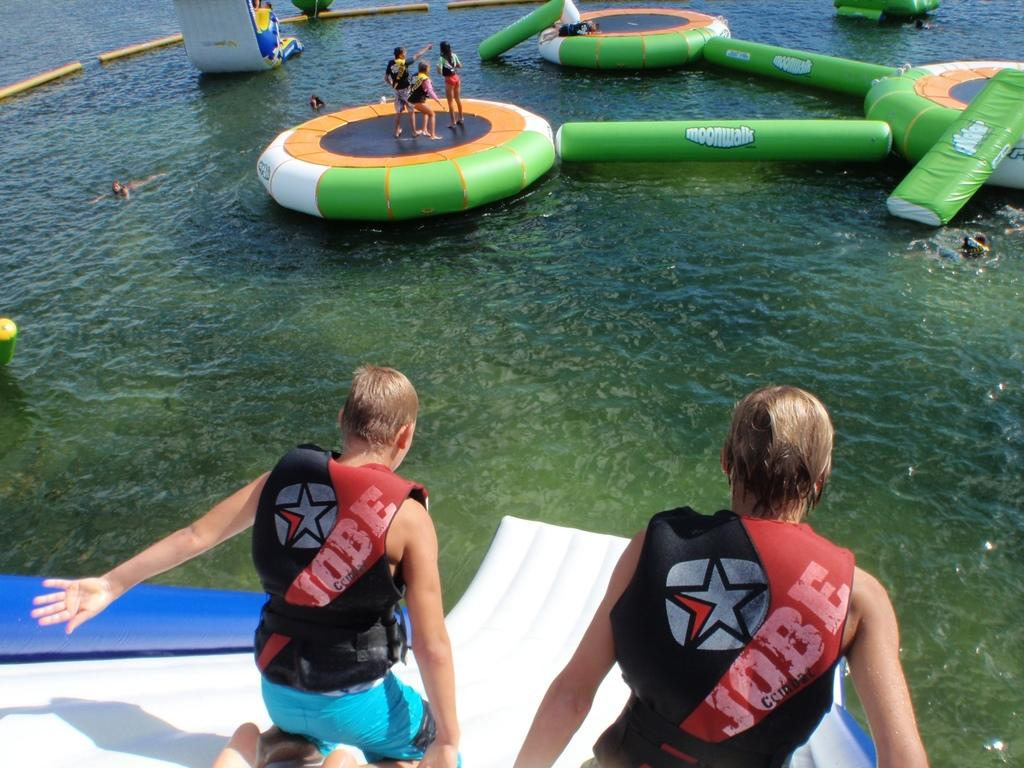What is floating on the surface of the water in the image? There are inflatable objects on the surface of the water. How many people are standing on the inflatable objects? Three persons are standing on the inflatable objects. Can you describe the people at the bottom of the image? Two persons are visible at the bottom of the image. What type of ticket is required to access the inflatable objects in the image? There is no mention of a ticket or any requirement to access the inflatable objects in the image. 